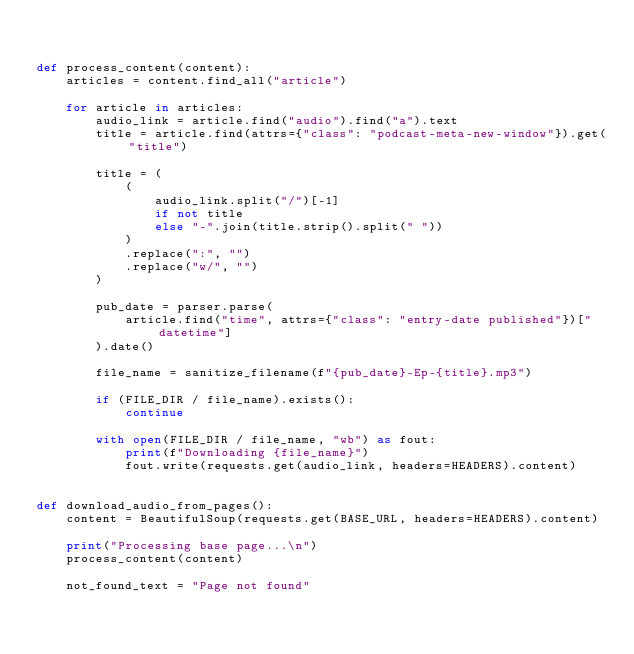Convert code to text. <code><loc_0><loc_0><loc_500><loc_500><_Python_>

def process_content(content):
    articles = content.find_all("article")

    for article in articles:
        audio_link = article.find("audio").find("a").text
        title = article.find(attrs={"class": "podcast-meta-new-window"}).get("title")

        title = (
            (
                audio_link.split("/")[-1]
                if not title
                else "-".join(title.strip().split(" "))
            )
            .replace(":", "")
            .replace("w/", "")
        )

        pub_date = parser.parse(
            article.find("time", attrs={"class": "entry-date published"})["datetime"]
        ).date()

        file_name = sanitize_filename(f"{pub_date}-Ep-{title}.mp3")

        if (FILE_DIR / file_name).exists():
            continue

        with open(FILE_DIR / file_name, "wb") as fout:
            print(f"Downloading {file_name}")
            fout.write(requests.get(audio_link, headers=HEADERS).content)


def download_audio_from_pages():
    content = BeautifulSoup(requests.get(BASE_URL, headers=HEADERS).content)

    print("Processing base page...\n")
    process_content(content)

    not_found_text = "Page not found"
</code> 